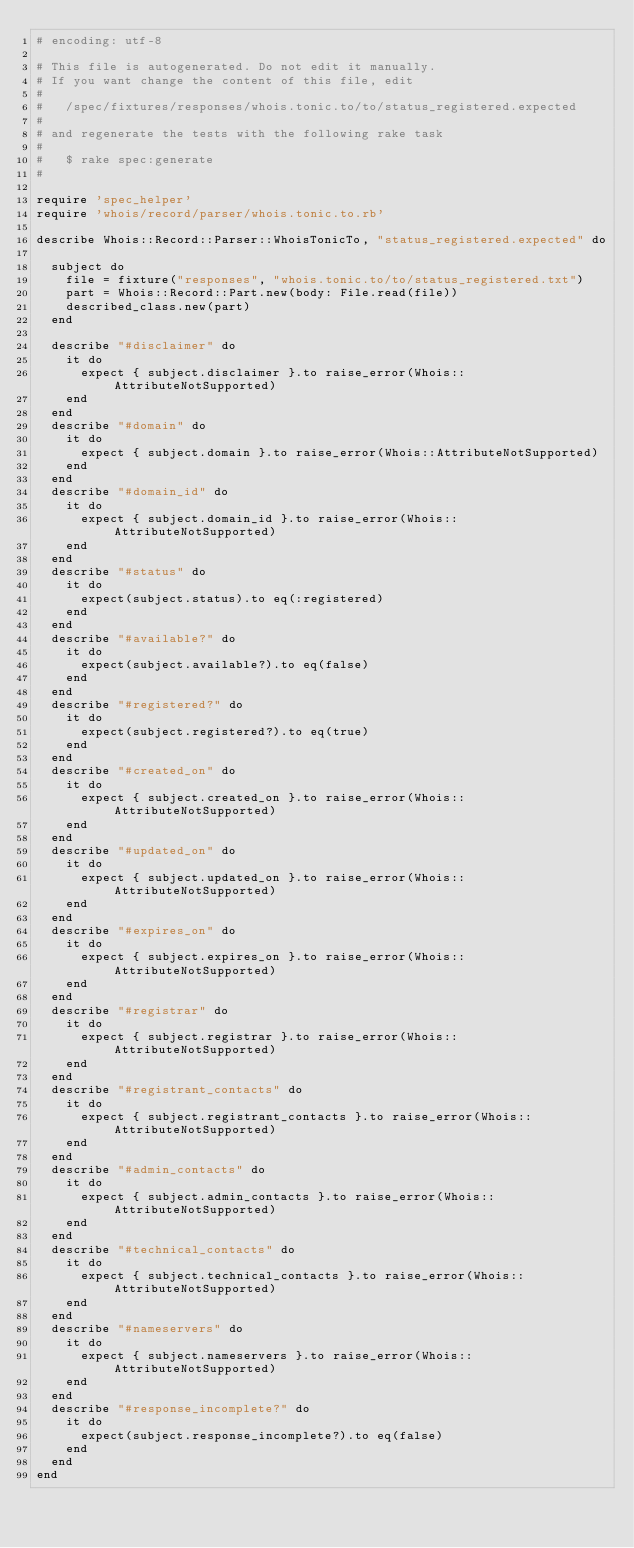<code> <loc_0><loc_0><loc_500><loc_500><_Ruby_># encoding: utf-8

# This file is autogenerated. Do not edit it manually.
# If you want change the content of this file, edit
#
#   /spec/fixtures/responses/whois.tonic.to/to/status_registered.expected
#
# and regenerate the tests with the following rake task
#
#   $ rake spec:generate
#

require 'spec_helper'
require 'whois/record/parser/whois.tonic.to.rb'

describe Whois::Record::Parser::WhoisTonicTo, "status_registered.expected" do

  subject do
    file = fixture("responses", "whois.tonic.to/to/status_registered.txt")
    part = Whois::Record::Part.new(body: File.read(file))
    described_class.new(part)
  end

  describe "#disclaimer" do
    it do
      expect { subject.disclaimer }.to raise_error(Whois::AttributeNotSupported)
    end
  end
  describe "#domain" do
    it do
      expect { subject.domain }.to raise_error(Whois::AttributeNotSupported)
    end
  end
  describe "#domain_id" do
    it do
      expect { subject.domain_id }.to raise_error(Whois::AttributeNotSupported)
    end
  end
  describe "#status" do
    it do
      expect(subject.status).to eq(:registered)
    end
  end
  describe "#available?" do
    it do
      expect(subject.available?).to eq(false)
    end
  end
  describe "#registered?" do
    it do
      expect(subject.registered?).to eq(true)
    end
  end
  describe "#created_on" do
    it do
      expect { subject.created_on }.to raise_error(Whois::AttributeNotSupported)
    end
  end
  describe "#updated_on" do
    it do
      expect { subject.updated_on }.to raise_error(Whois::AttributeNotSupported)
    end
  end
  describe "#expires_on" do
    it do
      expect { subject.expires_on }.to raise_error(Whois::AttributeNotSupported)
    end
  end
  describe "#registrar" do
    it do
      expect { subject.registrar }.to raise_error(Whois::AttributeNotSupported)
    end
  end
  describe "#registrant_contacts" do
    it do
      expect { subject.registrant_contacts }.to raise_error(Whois::AttributeNotSupported)
    end
  end
  describe "#admin_contacts" do
    it do
      expect { subject.admin_contacts }.to raise_error(Whois::AttributeNotSupported)
    end
  end
  describe "#technical_contacts" do
    it do
      expect { subject.technical_contacts }.to raise_error(Whois::AttributeNotSupported)
    end
  end
  describe "#nameservers" do
    it do
      expect { subject.nameservers }.to raise_error(Whois::AttributeNotSupported)
    end
  end
  describe "#response_incomplete?" do
    it do
      expect(subject.response_incomplete?).to eq(false)
    end
  end
end
</code> 